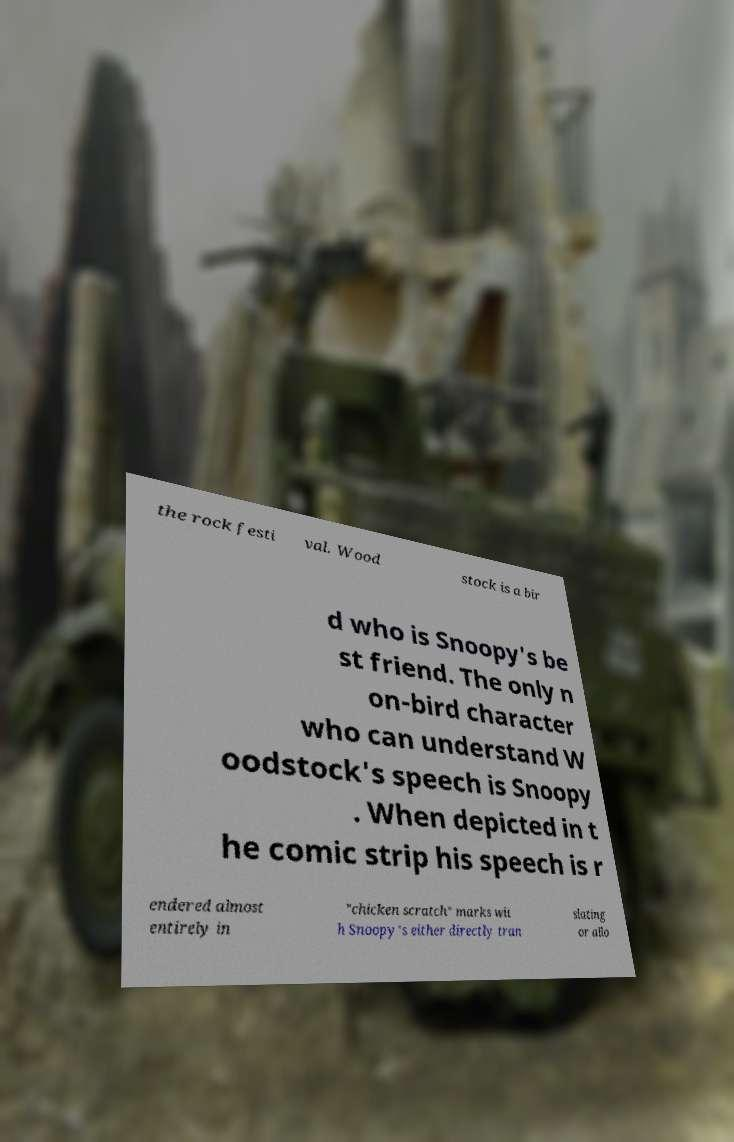What messages or text are displayed in this image? I need them in a readable, typed format. the rock festi val. Wood stock is a bir d who is Snoopy's be st friend. The only n on-bird character who can understand W oodstock's speech is Snoopy . When depicted in t he comic strip his speech is r endered almost entirely in "chicken scratch" marks wit h Snoopy's either directly tran slating or allo 